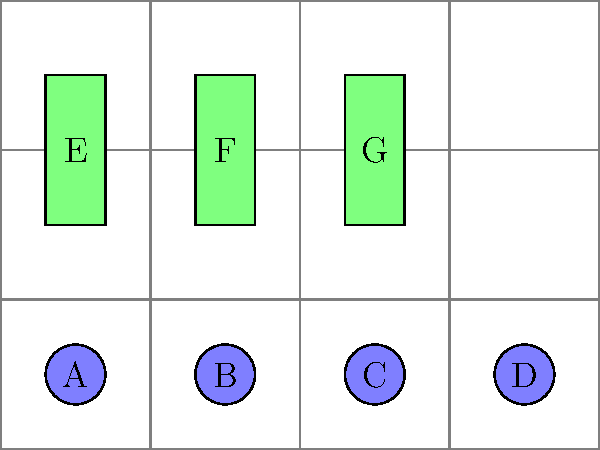In the given product arrangement diagram, which visual merchandising principle is being demonstrated, and how can it be improved to potentially increase sales? 1. Analyze the current layout:
   - Circular products (A, B, C, D) are arranged in a straight line at the bottom.
   - Rectangular products (E, F, G) are placed in a row above.

2. Identify the principle:
   - This layout demonstrates the "Symmetry and Balance" principle of visual merchandising.
   - The arrangement is visually balanced but lacks dynamic appeal.

3. Consider improvement opportunities:
   - Create a focal point: Rearrange products to draw attention to a central area.
   - Use the "Rule of Thirds": Divide the space into a 3x3 grid and place key items at intersection points.
   - Implement a "Pyramid" or "Triangle" display: Arrange products in a triangular shape for visual interest.
   - Vary product heights: Mix tall and short items to create visual rhythm.

4. Propose a specific improvement:
   - Implement a pyramid display:
     - Place one rectangular product (e.g., F) at the top center.
     - Arrange two circular products (e.g., B and C) below it.
     - Position the remaining products at the base.

5. Expected outcome:
   - This arrangement would create a more dynamic display.
   - It guides the customer's eye through the product range.
   - The central focus can highlight featured or high-margin items.
Answer: Symmetry and Balance; improve with pyramid display 